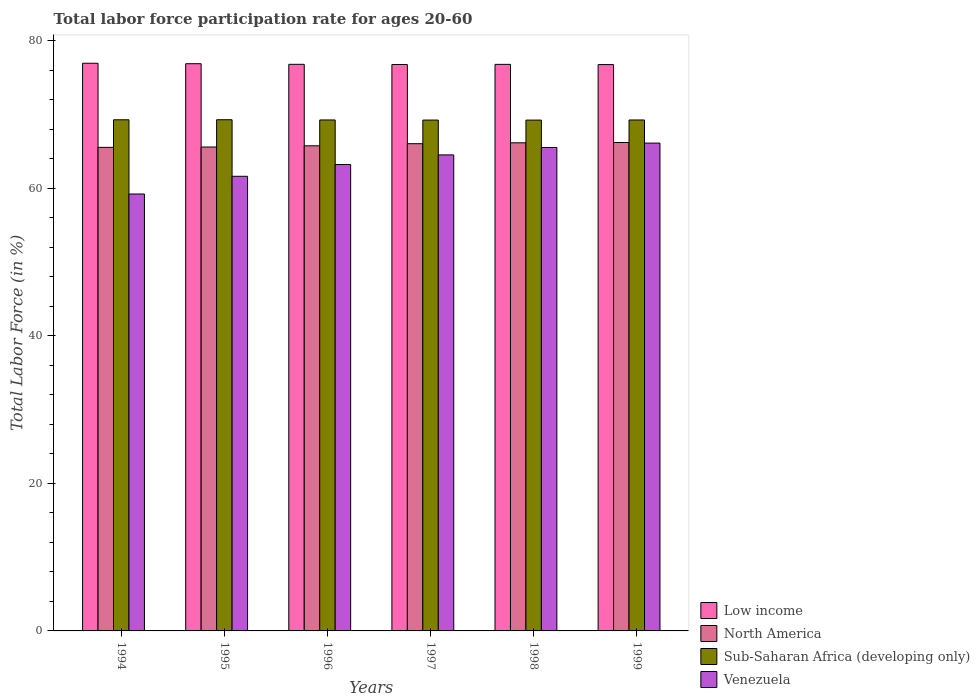How many bars are there on the 2nd tick from the left?
Give a very brief answer. 4. How many bars are there on the 2nd tick from the right?
Provide a short and direct response. 4. What is the label of the 1st group of bars from the left?
Keep it short and to the point. 1994. What is the labor force participation rate in Low income in 1994?
Offer a very short reply. 76.92. Across all years, what is the maximum labor force participation rate in Low income?
Your answer should be compact. 76.92. Across all years, what is the minimum labor force participation rate in Venezuela?
Offer a terse response. 59.2. In which year was the labor force participation rate in Sub-Saharan Africa (developing only) minimum?
Provide a succinct answer. 1998. What is the total labor force participation rate in Low income in the graph?
Your answer should be very brief. 460.79. What is the difference between the labor force participation rate in Low income in 1997 and that in 1999?
Give a very brief answer. 0.01. What is the difference between the labor force participation rate in North America in 1998 and the labor force participation rate in Low income in 1994?
Provide a succinct answer. -10.78. What is the average labor force participation rate in North America per year?
Make the answer very short. 65.86. In the year 1997, what is the difference between the labor force participation rate in North America and labor force participation rate in Sub-Saharan Africa (developing only)?
Provide a succinct answer. -3.2. In how many years, is the labor force participation rate in Venezuela greater than 8 %?
Give a very brief answer. 6. What is the ratio of the labor force participation rate in Venezuela in 1995 to that in 1997?
Make the answer very short. 0.96. Is the labor force participation rate in Sub-Saharan Africa (developing only) in 1995 less than that in 1997?
Make the answer very short. No. What is the difference between the highest and the second highest labor force participation rate in Sub-Saharan Africa (developing only)?
Provide a short and direct response. 0.01. What is the difference between the highest and the lowest labor force participation rate in North America?
Make the answer very short. 0.66. In how many years, is the labor force participation rate in Venezuela greater than the average labor force participation rate in Venezuela taken over all years?
Give a very brief answer. 3. Is the sum of the labor force participation rate in Venezuela in 1994 and 1996 greater than the maximum labor force participation rate in North America across all years?
Make the answer very short. Yes. Is it the case that in every year, the sum of the labor force participation rate in Sub-Saharan Africa (developing only) and labor force participation rate in Low income is greater than the sum of labor force participation rate in North America and labor force participation rate in Venezuela?
Give a very brief answer. Yes. What does the 3rd bar from the left in 1995 represents?
Your answer should be compact. Sub-Saharan Africa (developing only). What does the 1st bar from the right in 1998 represents?
Keep it short and to the point. Venezuela. Are all the bars in the graph horizontal?
Your answer should be compact. No. How many years are there in the graph?
Keep it short and to the point. 6. Does the graph contain any zero values?
Keep it short and to the point. No. Where does the legend appear in the graph?
Provide a succinct answer. Bottom right. How are the legend labels stacked?
Provide a short and direct response. Vertical. What is the title of the graph?
Provide a succinct answer. Total labor force participation rate for ages 20-60. Does "Fiji" appear as one of the legend labels in the graph?
Offer a terse response. No. What is the label or title of the Y-axis?
Your response must be concise. Total Labor Force (in %). What is the Total Labor Force (in %) of Low income in 1994?
Give a very brief answer. 76.92. What is the Total Labor Force (in %) in North America in 1994?
Keep it short and to the point. 65.52. What is the Total Labor Force (in %) in Sub-Saharan Africa (developing only) in 1994?
Provide a short and direct response. 69.26. What is the Total Labor Force (in %) of Venezuela in 1994?
Make the answer very short. 59.2. What is the Total Labor Force (in %) of Low income in 1995?
Offer a very short reply. 76.86. What is the Total Labor Force (in %) of North America in 1995?
Offer a terse response. 65.57. What is the Total Labor Force (in %) of Sub-Saharan Africa (developing only) in 1995?
Provide a short and direct response. 69.26. What is the Total Labor Force (in %) in Venezuela in 1995?
Your answer should be compact. 61.6. What is the Total Labor Force (in %) of Low income in 1996?
Your response must be concise. 76.77. What is the Total Labor Force (in %) of North America in 1996?
Provide a succinct answer. 65.73. What is the Total Labor Force (in %) in Sub-Saharan Africa (developing only) in 1996?
Give a very brief answer. 69.23. What is the Total Labor Force (in %) in Venezuela in 1996?
Provide a short and direct response. 63.2. What is the Total Labor Force (in %) in Low income in 1997?
Your answer should be very brief. 76.74. What is the Total Labor Force (in %) of North America in 1997?
Ensure brevity in your answer.  66.02. What is the Total Labor Force (in %) of Sub-Saharan Africa (developing only) in 1997?
Offer a terse response. 69.22. What is the Total Labor Force (in %) of Venezuela in 1997?
Provide a succinct answer. 64.5. What is the Total Labor Force (in %) in Low income in 1998?
Your answer should be compact. 76.77. What is the Total Labor Force (in %) in North America in 1998?
Your answer should be very brief. 66.14. What is the Total Labor Force (in %) of Sub-Saharan Africa (developing only) in 1998?
Keep it short and to the point. 69.21. What is the Total Labor Force (in %) of Venezuela in 1998?
Offer a very short reply. 65.5. What is the Total Labor Force (in %) in Low income in 1999?
Offer a very short reply. 76.74. What is the Total Labor Force (in %) in North America in 1999?
Your response must be concise. 66.18. What is the Total Labor Force (in %) of Sub-Saharan Africa (developing only) in 1999?
Provide a succinct answer. 69.23. What is the Total Labor Force (in %) of Venezuela in 1999?
Make the answer very short. 66.1. Across all years, what is the maximum Total Labor Force (in %) in Low income?
Keep it short and to the point. 76.92. Across all years, what is the maximum Total Labor Force (in %) of North America?
Ensure brevity in your answer.  66.18. Across all years, what is the maximum Total Labor Force (in %) of Sub-Saharan Africa (developing only)?
Offer a terse response. 69.26. Across all years, what is the maximum Total Labor Force (in %) in Venezuela?
Provide a succinct answer. 66.1. Across all years, what is the minimum Total Labor Force (in %) of Low income?
Your response must be concise. 76.74. Across all years, what is the minimum Total Labor Force (in %) of North America?
Your response must be concise. 65.52. Across all years, what is the minimum Total Labor Force (in %) in Sub-Saharan Africa (developing only)?
Offer a terse response. 69.21. Across all years, what is the minimum Total Labor Force (in %) in Venezuela?
Offer a very short reply. 59.2. What is the total Total Labor Force (in %) in Low income in the graph?
Your answer should be compact. 460.79. What is the total Total Labor Force (in %) in North America in the graph?
Offer a terse response. 395.15. What is the total Total Labor Force (in %) of Sub-Saharan Africa (developing only) in the graph?
Keep it short and to the point. 415.42. What is the total Total Labor Force (in %) in Venezuela in the graph?
Your response must be concise. 380.1. What is the difference between the Total Labor Force (in %) of Low income in 1994 and that in 1995?
Offer a very short reply. 0.06. What is the difference between the Total Labor Force (in %) of North America in 1994 and that in 1995?
Keep it short and to the point. -0.05. What is the difference between the Total Labor Force (in %) in Sub-Saharan Africa (developing only) in 1994 and that in 1995?
Make the answer very short. -0.01. What is the difference between the Total Labor Force (in %) of Low income in 1994 and that in 1996?
Your response must be concise. 0.14. What is the difference between the Total Labor Force (in %) in North America in 1994 and that in 1996?
Keep it short and to the point. -0.21. What is the difference between the Total Labor Force (in %) in Sub-Saharan Africa (developing only) in 1994 and that in 1996?
Your response must be concise. 0.02. What is the difference between the Total Labor Force (in %) of Venezuela in 1994 and that in 1996?
Ensure brevity in your answer.  -4. What is the difference between the Total Labor Force (in %) of Low income in 1994 and that in 1997?
Offer a terse response. 0.17. What is the difference between the Total Labor Force (in %) of North America in 1994 and that in 1997?
Keep it short and to the point. -0.5. What is the difference between the Total Labor Force (in %) of Sub-Saharan Africa (developing only) in 1994 and that in 1997?
Provide a succinct answer. 0.04. What is the difference between the Total Labor Force (in %) of Venezuela in 1994 and that in 1997?
Make the answer very short. -5.3. What is the difference between the Total Labor Force (in %) of Low income in 1994 and that in 1998?
Your response must be concise. 0.15. What is the difference between the Total Labor Force (in %) of North America in 1994 and that in 1998?
Keep it short and to the point. -0.62. What is the difference between the Total Labor Force (in %) in Sub-Saharan Africa (developing only) in 1994 and that in 1998?
Your answer should be compact. 0.04. What is the difference between the Total Labor Force (in %) in Venezuela in 1994 and that in 1998?
Your answer should be compact. -6.3. What is the difference between the Total Labor Force (in %) in Low income in 1994 and that in 1999?
Keep it short and to the point. 0.18. What is the difference between the Total Labor Force (in %) in North America in 1994 and that in 1999?
Your response must be concise. -0.66. What is the difference between the Total Labor Force (in %) of Sub-Saharan Africa (developing only) in 1994 and that in 1999?
Your response must be concise. 0.03. What is the difference between the Total Labor Force (in %) in Venezuela in 1994 and that in 1999?
Offer a very short reply. -6.9. What is the difference between the Total Labor Force (in %) of Low income in 1995 and that in 1996?
Provide a short and direct response. 0.08. What is the difference between the Total Labor Force (in %) of North America in 1995 and that in 1996?
Keep it short and to the point. -0.16. What is the difference between the Total Labor Force (in %) of Sub-Saharan Africa (developing only) in 1995 and that in 1996?
Your response must be concise. 0.03. What is the difference between the Total Labor Force (in %) of Venezuela in 1995 and that in 1996?
Your answer should be very brief. -1.6. What is the difference between the Total Labor Force (in %) of Low income in 1995 and that in 1997?
Provide a succinct answer. 0.11. What is the difference between the Total Labor Force (in %) in North America in 1995 and that in 1997?
Your answer should be very brief. -0.45. What is the difference between the Total Labor Force (in %) of Sub-Saharan Africa (developing only) in 1995 and that in 1997?
Your answer should be very brief. 0.04. What is the difference between the Total Labor Force (in %) of Venezuela in 1995 and that in 1997?
Your answer should be very brief. -2.9. What is the difference between the Total Labor Force (in %) of Low income in 1995 and that in 1998?
Your answer should be compact. 0.09. What is the difference between the Total Labor Force (in %) in North America in 1995 and that in 1998?
Your answer should be compact. -0.57. What is the difference between the Total Labor Force (in %) in Sub-Saharan Africa (developing only) in 1995 and that in 1998?
Keep it short and to the point. 0.05. What is the difference between the Total Labor Force (in %) in Venezuela in 1995 and that in 1998?
Make the answer very short. -3.9. What is the difference between the Total Labor Force (in %) of Low income in 1995 and that in 1999?
Your response must be concise. 0.12. What is the difference between the Total Labor Force (in %) of North America in 1995 and that in 1999?
Keep it short and to the point. -0.61. What is the difference between the Total Labor Force (in %) in Sub-Saharan Africa (developing only) in 1995 and that in 1999?
Provide a short and direct response. 0.03. What is the difference between the Total Labor Force (in %) of Venezuela in 1995 and that in 1999?
Keep it short and to the point. -4.5. What is the difference between the Total Labor Force (in %) in Low income in 1996 and that in 1997?
Keep it short and to the point. 0.03. What is the difference between the Total Labor Force (in %) of North America in 1996 and that in 1997?
Your response must be concise. -0.29. What is the difference between the Total Labor Force (in %) of Sub-Saharan Africa (developing only) in 1996 and that in 1997?
Your answer should be very brief. 0.01. What is the difference between the Total Labor Force (in %) of Low income in 1996 and that in 1998?
Provide a short and direct response. 0.01. What is the difference between the Total Labor Force (in %) of North America in 1996 and that in 1998?
Keep it short and to the point. -0.41. What is the difference between the Total Labor Force (in %) of Sub-Saharan Africa (developing only) in 1996 and that in 1998?
Keep it short and to the point. 0.02. What is the difference between the Total Labor Force (in %) in Venezuela in 1996 and that in 1998?
Give a very brief answer. -2.3. What is the difference between the Total Labor Force (in %) of Low income in 1996 and that in 1999?
Ensure brevity in your answer.  0.04. What is the difference between the Total Labor Force (in %) in North America in 1996 and that in 1999?
Ensure brevity in your answer.  -0.45. What is the difference between the Total Labor Force (in %) of Sub-Saharan Africa (developing only) in 1996 and that in 1999?
Your response must be concise. 0. What is the difference between the Total Labor Force (in %) in Low income in 1997 and that in 1998?
Provide a short and direct response. -0.02. What is the difference between the Total Labor Force (in %) of North America in 1997 and that in 1998?
Your answer should be compact. -0.12. What is the difference between the Total Labor Force (in %) in Sub-Saharan Africa (developing only) in 1997 and that in 1998?
Provide a short and direct response. 0. What is the difference between the Total Labor Force (in %) of Low income in 1997 and that in 1999?
Keep it short and to the point. 0.01. What is the difference between the Total Labor Force (in %) in North America in 1997 and that in 1999?
Your answer should be very brief. -0.16. What is the difference between the Total Labor Force (in %) of Sub-Saharan Africa (developing only) in 1997 and that in 1999?
Provide a short and direct response. -0.01. What is the difference between the Total Labor Force (in %) in Low income in 1998 and that in 1999?
Offer a very short reply. 0.03. What is the difference between the Total Labor Force (in %) of North America in 1998 and that in 1999?
Ensure brevity in your answer.  -0.04. What is the difference between the Total Labor Force (in %) in Sub-Saharan Africa (developing only) in 1998 and that in 1999?
Offer a very short reply. -0.02. What is the difference between the Total Labor Force (in %) in Venezuela in 1998 and that in 1999?
Offer a very short reply. -0.6. What is the difference between the Total Labor Force (in %) in Low income in 1994 and the Total Labor Force (in %) in North America in 1995?
Ensure brevity in your answer.  11.35. What is the difference between the Total Labor Force (in %) in Low income in 1994 and the Total Labor Force (in %) in Sub-Saharan Africa (developing only) in 1995?
Make the answer very short. 7.65. What is the difference between the Total Labor Force (in %) of Low income in 1994 and the Total Labor Force (in %) of Venezuela in 1995?
Keep it short and to the point. 15.32. What is the difference between the Total Labor Force (in %) in North America in 1994 and the Total Labor Force (in %) in Sub-Saharan Africa (developing only) in 1995?
Provide a succinct answer. -3.74. What is the difference between the Total Labor Force (in %) in North America in 1994 and the Total Labor Force (in %) in Venezuela in 1995?
Ensure brevity in your answer.  3.92. What is the difference between the Total Labor Force (in %) in Sub-Saharan Africa (developing only) in 1994 and the Total Labor Force (in %) in Venezuela in 1995?
Give a very brief answer. 7.66. What is the difference between the Total Labor Force (in %) of Low income in 1994 and the Total Labor Force (in %) of North America in 1996?
Ensure brevity in your answer.  11.19. What is the difference between the Total Labor Force (in %) of Low income in 1994 and the Total Labor Force (in %) of Sub-Saharan Africa (developing only) in 1996?
Your answer should be compact. 7.68. What is the difference between the Total Labor Force (in %) in Low income in 1994 and the Total Labor Force (in %) in Venezuela in 1996?
Keep it short and to the point. 13.72. What is the difference between the Total Labor Force (in %) in North America in 1994 and the Total Labor Force (in %) in Sub-Saharan Africa (developing only) in 1996?
Offer a terse response. -3.71. What is the difference between the Total Labor Force (in %) in North America in 1994 and the Total Labor Force (in %) in Venezuela in 1996?
Make the answer very short. 2.32. What is the difference between the Total Labor Force (in %) in Sub-Saharan Africa (developing only) in 1994 and the Total Labor Force (in %) in Venezuela in 1996?
Provide a succinct answer. 6.06. What is the difference between the Total Labor Force (in %) in Low income in 1994 and the Total Labor Force (in %) in North America in 1997?
Offer a very short reply. 10.9. What is the difference between the Total Labor Force (in %) in Low income in 1994 and the Total Labor Force (in %) in Sub-Saharan Africa (developing only) in 1997?
Offer a very short reply. 7.7. What is the difference between the Total Labor Force (in %) in Low income in 1994 and the Total Labor Force (in %) in Venezuela in 1997?
Make the answer very short. 12.42. What is the difference between the Total Labor Force (in %) of North America in 1994 and the Total Labor Force (in %) of Sub-Saharan Africa (developing only) in 1997?
Offer a terse response. -3.7. What is the difference between the Total Labor Force (in %) of North America in 1994 and the Total Labor Force (in %) of Venezuela in 1997?
Offer a very short reply. 1.02. What is the difference between the Total Labor Force (in %) in Sub-Saharan Africa (developing only) in 1994 and the Total Labor Force (in %) in Venezuela in 1997?
Your answer should be very brief. 4.76. What is the difference between the Total Labor Force (in %) in Low income in 1994 and the Total Labor Force (in %) in North America in 1998?
Your answer should be compact. 10.78. What is the difference between the Total Labor Force (in %) in Low income in 1994 and the Total Labor Force (in %) in Sub-Saharan Africa (developing only) in 1998?
Make the answer very short. 7.7. What is the difference between the Total Labor Force (in %) in Low income in 1994 and the Total Labor Force (in %) in Venezuela in 1998?
Make the answer very short. 11.42. What is the difference between the Total Labor Force (in %) of North America in 1994 and the Total Labor Force (in %) of Sub-Saharan Africa (developing only) in 1998?
Provide a succinct answer. -3.69. What is the difference between the Total Labor Force (in %) in North America in 1994 and the Total Labor Force (in %) in Venezuela in 1998?
Give a very brief answer. 0.02. What is the difference between the Total Labor Force (in %) of Sub-Saharan Africa (developing only) in 1994 and the Total Labor Force (in %) of Venezuela in 1998?
Provide a succinct answer. 3.76. What is the difference between the Total Labor Force (in %) in Low income in 1994 and the Total Labor Force (in %) in North America in 1999?
Provide a short and direct response. 10.74. What is the difference between the Total Labor Force (in %) of Low income in 1994 and the Total Labor Force (in %) of Sub-Saharan Africa (developing only) in 1999?
Your answer should be very brief. 7.68. What is the difference between the Total Labor Force (in %) of Low income in 1994 and the Total Labor Force (in %) of Venezuela in 1999?
Offer a terse response. 10.82. What is the difference between the Total Labor Force (in %) in North America in 1994 and the Total Labor Force (in %) in Sub-Saharan Africa (developing only) in 1999?
Ensure brevity in your answer.  -3.71. What is the difference between the Total Labor Force (in %) of North America in 1994 and the Total Labor Force (in %) of Venezuela in 1999?
Provide a succinct answer. -0.58. What is the difference between the Total Labor Force (in %) in Sub-Saharan Africa (developing only) in 1994 and the Total Labor Force (in %) in Venezuela in 1999?
Provide a succinct answer. 3.16. What is the difference between the Total Labor Force (in %) of Low income in 1995 and the Total Labor Force (in %) of North America in 1996?
Offer a very short reply. 11.13. What is the difference between the Total Labor Force (in %) of Low income in 1995 and the Total Labor Force (in %) of Sub-Saharan Africa (developing only) in 1996?
Provide a short and direct response. 7.62. What is the difference between the Total Labor Force (in %) of Low income in 1995 and the Total Labor Force (in %) of Venezuela in 1996?
Offer a very short reply. 13.66. What is the difference between the Total Labor Force (in %) of North America in 1995 and the Total Labor Force (in %) of Sub-Saharan Africa (developing only) in 1996?
Your answer should be compact. -3.66. What is the difference between the Total Labor Force (in %) of North America in 1995 and the Total Labor Force (in %) of Venezuela in 1996?
Provide a short and direct response. 2.37. What is the difference between the Total Labor Force (in %) of Sub-Saharan Africa (developing only) in 1995 and the Total Labor Force (in %) of Venezuela in 1996?
Offer a terse response. 6.06. What is the difference between the Total Labor Force (in %) of Low income in 1995 and the Total Labor Force (in %) of North America in 1997?
Provide a short and direct response. 10.84. What is the difference between the Total Labor Force (in %) in Low income in 1995 and the Total Labor Force (in %) in Sub-Saharan Africa (developing only) in 1997?
Offer a terse response. 7.64. What is the difference between the Total Labor Force (in %) of Low income in 1995 and the Total Labor Force (in %) of Venezuela in 1997?
Your response must be concise. 12.36. What is the difference between the Total Labor Force (in %) of North America in 1995 and the Total Labor Force (in %) of Sub-Saharan Africa (developing only) in 1997?
Your answer should be compact. -3.65. What is the difference between the Total Labor Force (in %) in North America in 1995 and the Total Labor Force (in %) in Venezuela in 1997?
Ensure brevity in your answer.  1.07. What is the difference between the Total Labor Force (in %) in Sub-Saharan Africa (developing only) in 1995 and the Total Labor Force (in %) in Venezuela in 1997?
Offer a terse response. 4.76. What is the difference between the Total Labor Force (in %) of Low income in 1995 and the Total Labor Force (in %) of North America in 1998?
Offer a very short reply. 10.72. What is the difference between the Total Labor Force (in %) of Low income in 1995 and the Total Labor Force (in %) of Sub-Saharan Africa (developing only) in 1998?
Offer a terse response. 7.64. What is the difference between the Total Labor Force (in %) in Low income in 1995 and the Total Labor Force (in %) in Venezuela in 1998?
Provide a short and direct response. 11.36. What is the difference between the Total Labor Force (in %) in North America in 1995 and the Total Labor Force (in %) in Sub-Saharan Africa (developing only) in 1998?
Your answer should be very brief. -3.64. What is the difference between the Total Labor Force (in %) in North America in 1995 and the Total Labor Force (in %) in Venezuela in 1998?
Provide a succinct answer. 0.07. What is the difference between the Total Labor Force (in %) of Sub-Saharan Africa (developing only) in 1995 and the Total Labor Force (in %) of Venezuela in 1998?
Your answer should be compact. 3.76. What is the difference between the Total Labor Force (in %) in Low income in 1995 and the Total Labor Force (in %) in North America in 1999?
Your answer should be very brief. 10.68. What is the difference between the Total Labor Force (in %) in Low income in 1995 and the Total Labor Force (in %) in Sub-Saharan Africa (developing only) in 1999?
Make the answer very short. 7.62. What is the difference between the Total Labor Force (in %) in Low income in 1995 and the Total Labor Force (in %) in Venezuela in 1999?
Offer a very short reply. 10.76. What is the difference between the Total Labor Force (in %) of North America in 1995 and the Total Labor Force (in %) of Sub-Saharan Africa (developing only) in 1999?
Ensure brevity in your answer.  -3.66. What is the difference between the Total Labor Force (in %) of North America in 1995 and the Total Labor Force (in %) of Venezuela in 1999?
Your answer should be very brief. -0.53. What is the difference between the Total Labor Force (in %) in Sub-Saharan Africa (developing only) in 1995 and the Total Labor Force (in %) in Venezuela in 1999?
Provide a short and direct response. 3.16. What is the difference between the Total Labor Force (in %) of Low income in 1996 and the Total Labor Force (in %) of North America in 1997?
Your answer should be compact. 10.75. What is the difference between the Total Labor Force (in %) in Low income in 1996 and the Total Labor Force (in %) in Sub-Saharan Africa (developing only) in 1997?
Offer a very short reply. 7.55. What is the difference between the Total Labor Force (in %) in Low income in 1996 and the Total Labor Force (in %) in Venezuela in 1997?
Offer a terse response. 12.27. What is the difference between the Total Labor Force (in %) in North America in 1996 and the Total Labor Force (in %) in Sub-Saharan Africa (developing only) in 1997?
Ensure brevity in your answer.  -3.49. What is the difference between the Total Labor Force (in %) of North America in 1996 and the Total Labor Force (in %) of Venezuela in 1997?
Offer a very short reply. 1.23. What is the difference between the Total Labor Force (in %) of Sub-Saharan Africa (developing only) in 1996 and the Total Labor Force (in %) of Venezuela in 1997?
Make the answer very short. 4.73. What is the difference between the Total Labor Force (in %) in Low income in 1996 and the Total Labor Force (in %) in North America in 1998?
Provide a short and direct response. 10.63. What is the difference between the Total Labor Force (in %) of Low income in 1996 and the Total Labor Force (in %) of Sub-Saharan Africa (developing only) in 1998?
Give a very brief answer. 7.56. What is the difference between the Total Labor Force (in %) in Low income in 1996 and the Total Labor Force (in %) in Venezuela in 1998?
Offer a terse response. 11.27. What is the difference between the Total Labor Force (in %) of North America in 1996 and the Total Labor Force (in %) of Sub-Saharan Africa (developing only) in 1998?
Offer a terse response. -3.49. What is the difference between the Total Labor Force (in %) of North America in 1996 and the Total Labor Force (in %) of Venezuela in 1998?
Keep it short and to the point. 0.23. What is the difference between the Total Labor Force (in %) of Sub-Saharan Africa (developing only) in 1996 and the Total Labor Force (in %) of Venezuela in 1998?
Provide a short and direct response. 3.73. What is the difference between the Total Labor Force (in %) of Low income in 1996 and the Total Labor Force (in %) of North America in 1999?
Your response must be concise. 10.59. What is the difference between the Total Labor Force (in %) of Low income in 1996 and the Total Labor Force (in %) of Sub-Saharan Africa (developing only) in 1999?
Provide a succinct answer. 7.54. What is the difference between the Total Labor Force (in %) in Low income in 1996 and the Total Labor Force (in %) in Venezuela in 1999?
Ensure brevity in your answer.  10.67. What is the difference between the Total Labor Force (in %) of North America in 1996 and the Total Labor Force (in %) of Sub-Saharan Africa (developing only) in 1999?
Provide a succinct answer. -3.5. What is the difference between the Total Labor Force (in %) in North America in 1996 and the Total Labor Force (in %) in Venezuela in 1999?
Give a very brief answer. -0.37. What is the difference between the Total Labor Force (in %) of Sub-Saharan Africa (developing only) in 1996 and the Total Labor Force (in %) of Venezuela in 1999?
Make the answer very short. 3.13. What is the difference between the Total Labor Force (in %) in Low income in 1997 and the Total Labor Force (in %) in North America in 1998?
Offer a very short reply. 10.61. What is the difference between the Total Labor Force (in %) in Low income in 1997 and the Total Labor Force (in %) in Sub-Saharan Africa (developing only) in 1998?
Offer a terse response. 7.53. What is the difference between the Total Labor Force (in %) in Low income in 1997 and the Total Labor Force (in %) in Venezuela in 1998?
Your response must be concise. 11.24. What is the difference between the Total Labor Force (in %) in North America in 1997 and the Total Labor Force (in %) in Sub-Saharan Africa (developing only) in 1998?
Your answer should be very brief. -3.2. What is the difference between the Total Labor Force (in %) of North America in 1997 and the Total Labor Force (in %) of Venezuela in 1998?
Your answer should be compact. 0.52. What is the difference between the Total Labor Force (in %) in Sub-Saharan Africa (developing only) in 1997 and the Total Labor Force (in %) in Venezuela in 1998?
Keep it short and to the point. 3.72. What is the difference between the Total Labor Force (in %) in Low income in 1997 and the Total Labor Force (in %) in North America in 1999?
Offer a very short reply. 10.57. What is the difference between the Total Labor Force (in %) of Low income in 1997 and the Total Labor Force (in %) of Sub-Saharan Africa (developing only) in 1999?
Give a very brief answer. 7.51. What is the difference between the Total Labor Force (in %) in Low income in 1997 and the Total Labor Force (in %) in Venezuela in 1999?
Make the answer very short. 10.64. What is the difference between the Total Labor Force (in %) in North America in 1997 and the Total Labor Force (in %) in Sub-Saharan Africa (developing only) in 1999?
Your answer should be compact. -3.21. What is the difference between the Total Labor Force (in %) of North America in 1997 and the Total Labor Force (in %) of Venezuela in 1999?
Your answer should be compact. -0.08. What is the difference between the Total Labor Force (in %) of Sub-Saharan Africa (developing only) in 1997 and the Total Labor Force (in %) of Venezuela in 1999?
Your answer should be compact. 3.12. What is the difference between the Total Labor Force (in %) in Low income in 1998 and the Total Labor Force (in %) in North America in 1999?
Your answer should be very brief. 10.59. What is the difference between the Total Labor Force (in %) of Low income in 1998 and the Total Labor Force (in %) of Sub-Saharan Africa (developing only) in 1999?
Offer a very short reply. 7.53. What is the difference between the Total Labor Force (in %) in Low income in 1998 and the Total Labor Force (in %) in Venezuela in 1999?
Keep it short and to the point. 10.67. What is the difference between the Total Labor Force (in %) of North America in 1998 and the Total Labor Force (in %) of Sub-Saharan Africa (developing only) in 1999?
Make the answer very short. -3.09. What is the difference between the Total Labor Force (in %) in North America in 1998 and the Total Labor Force (in %) in Venezuela in 1999?
Offer a very short reply. 0.04. What is the difference between the Total Labor Force (in %) in Sub-Saharan Africa (developing only) in 1998 and the Total Labor Force (in %) in Venezuela in 1999?
Offer a terse response. 3.11. What is the average Total Labor Force (in %) in Low income per year?
Make the answer very short. 76.8. What is the average Total Labor Force (in %) of North America per year?
Give a very brief answer. 65.86. What is the average Total Labor Force (in %) of Sub-Saharan Africa (developing only) per year?
Your answer should be compact. 69.24. What is the average Total Labor Force (in %) of Venezuela per year?
Ensure brevity in your answer.  63.35. In the year 1994, what is the difference between the Total Labor Force (in %) of Low income and Total Labor Force (in %) of North America?
Provide a succinct answer. 11.4. In the year 1994, what is the difference between the Total Labor Force (in %) of Low income and Total Labor Force (in %) of Sub-Saharan Africa (developing only)?
Your answer should be compact. 7.66. In the year 1994, what is the difference between the Total Labor Force (in %) of Low income and Total Labor Force (in %) of Venezuela?
Keep it short and to the point. 17.72. In the year 1994, what is the difference between the Total Labor Force (in %) of North America and Total Labor Force (in %) of Sub-Saharan Africa (developing only)?
Provide a succinct answer. -3.74. In the year 1994, what is the difference between the Total Labor Force (in %) of North America and Total Labor Force (in %) of Venezuela?
Offer a terse response. 6.32. In the year 1994, what is the difference between the Total Labor Force (in %) in Sub-Saharan Africa (developing only) and Total Labor Force (in %) in Venezuela?
Your answer should be compact. 10.06. In the year 1995, what is the difference between the Total Labor Force (in %) in Low income and Total Labor Force (in %) in North America?
Ensure brevity in your answer.  11.29. In the year 1995, what is the difference between the Total Labor Force (in %) in Low income and Total Labor Force (in %) in Sub-Saharan Africa (developing only)?
Offer a very short reply. 7.59. In the year 1995, what is the difference between the Total Labor Force (in %) of Low income and Total Labor Force (in %) of Venezuela?
Your response must be concise. 15.26. In the year 1995, what is the difference between the Total Labor Force (in %) in North America and Total Labor Force (in %) in Sub-Saharan Africa (developing only)?
Your answer should be compact. -3.69. In the year 1995, what is the difference between the Total Labor Force (in %) in North America and Total Labor Force (in %) in Venezuela?
Provide a succinct answer. 3.97. In the year 1995, what is the difference between the Total Labor Force (in %) in Sub-Saharan Africa (developing only) and Total Labor Force (in %) in Venezuela?
Keep it short and to the point. 7.66. In the year 1996, what is the difference between the Total Labor Force (in %) of Low income and Total Labor Force (in %) of North America?
Provide a short and direct response. 11.04. In the year 1996, what is the difference between the Total Labor Force (in %) of Low income and Total Labor Force (in %) of Sub-Saharan Africa (developing only)?
Your answer should be compact. 7.54. In the year 1996, what is the difference between the Total Labor Force (in %) of Low income and Total Labor Force (in %) of Venezuela?
Give a very brief answer. 13.57. In the year 1996, what is the difference between the Total Labor Force (in %) of North America and Total Labor Force (in %) of Sub-Saharan Africa (developing only)?
Your answer should be compact. -3.5. In the year 1996, what is the difference between the Total Labor Force (in %) in North America and Total Labor Force (in %) in Venezuela?
Provide a short and direct response. 2.53. In the year 1996, what is the difference between the Total Labor Force (in %) of Sub-Saharan Africa (developing only) and Total Labor Force (in %) of Venezuela?
Give a very brief answer. 6.03. In the year 1997, what is the difference between the Total Labor Force (in %) in Low income and Total Labor Force (in %) in North America?
Your answer should be compact. 10.73. In the year 1997, what is the difference between the Total Labor Force (in %) in Low income and Total Labor Force (in %) in Sub-Saharan Africa (developing only)?
Offer a terse response. 7.53. In the year 1997, what is the difference between the Total Labor Force (in %) in Low income and Total Labor Force (in %) in Venezuela?
Your answer should be compact. 12.24. In the year 1997, what is the difference between the Total Labor Force (in %) of North America and Total Labor Force (in %) of Sub-Saharan Africa (developing only)?
Give a very brief answer. -3.2. In the year 1997, what is the difference between the Total Labor Force (in %) of North America and Total Labor Force (in %) of Venezuela?
Make the answer very short. 1.52. In the year 1997, what is the difference between the Total Labor Force (in %) in Sub-Saharan Africa (developing only) and Total Labor Force (in %) in Venezuela?
Offer a very short reply. 4.72. In the year 1998, what is the difference between the Total Labor Force (in %) of Low income and Total Labor Force (in %) of North America?
Your response must be concise. 10.63. In the year 1998, what is the difference between the Total Labor Force (in %) in Low income and Total Labor Force (in %) in Sub-Saharan Africa (developing only)?
Ensure brevity in your answer.  7.55. In the year 1998, what is the difference between the Total Labor Force (in %) of Low income and Total Labor Force (in %) of Venezuela?
Your response must be concise. 11.27. In the year 1998, what is the difference between the Total Labor Force (in %) in North America and Total Labor Force (in %) in Sub-Saharan Africa (developing only)?
Ensure brevity in your answer.  -3.08. In the year 1998, what is the difference between the Total Labor Force (in %) of North America and Total Labor Force (in %) of Venezuela?
Give a very brief answer. 0.64. In the year 1998, what is the difference between the Total Labor Force (in %) of Sub-Saharan Africa (developing only) and Total Labor Force (in %) of Venezuela?
Offer a terse response. 3.71. In the year 1999, what is the difference between the Total Labor Force (in %) of Low income and Total Labor Force (in %) of North America?
Provide a short and direct response. 10.56. In the year 1999, what is the difference between the Total Labor Force (in %) of Low income and Total Labor Force (in %) of Sub-Saharan Africa (developing only)?
Your answer should be compact. 7.51. In the year 1999, what is the difference between the Total Labor Force (in %) in Low income and Total Labor Force (in %) in Venezuela?
Ensure brevity in your answer.  10.64. In the year 1999, what is the difference between the Total Labor Force (in %) of North America and Total Labor Force (in %) of Sub-Saharan Africa (developing only)?
Give a very brief answer. -3.05. In the year 1999, what is the difference between the Total Labor Force (in %) of North America and Total Labor Force (in %) of Venezuela?
Give a very brief answer. 0.08. In the year 1999, what is the difference between the Total Labor Force (in %) in Sub-Saharan Africa (developing only) and Total Labor Force (in %) in Venezuela?
Give a very brief answer. 3.13. What is the ratio of the Total Labor Force (in %) of North America in 1994 to that in 1995?
Ensure brevity in your answer.  1. What is the ratio of the Total Labor Force (in %) of Sub-Saharan Africa (developing only) in 1994 to that in 1995?
Provide a succinct answer. 1. What is the ratio of the Total Labor Force (in %) of Venezuela in 1994 to that in 1995?
Keep it short and to the point. 0.96. What is the ratio of the Total Labor Force (in %) of Low income in 1994 to that in 1996?
Your response must be concise. 1. What is the ratio of the Total Labor Force (in %) of Sub-Saharan Africa (developing only) in 1994 to that in 1996?
Make the answer very short. 1. What is the ratio of the Total Labor Force (in %) in Venezuela in 1994 to that in 1996?
Give a very brief answer. 0.94. What is the ratio of the Total Labor Force (in %) of Low income in 1994 to that in 1997?
Ensure brevity in your answer.  1. What is the ratio of the Total Labor Force (in %) in Sub-Saharan Africa (developing only) in 1994 to that in 1997?
Provide a short and direct response. 1. What is the ratio of the Total Labor Force (in %) in Venezuela in 1994 to that in 1997?
Your answer should be compact. 0.92. What is the ratio of the Total Labor Force (in %) of Low income in 1994 to that in 1998?
Offer a terse response. 1. What is the ratio of the Total Labor Force (in %) of North America in 1994 to that in 1998?
Offer a terse response. 0.99. What is the ratio of the Total Labor Force (in %) of Venezuela in 1994 to that in 1998?
Your response must be concise. 0.9. What is the ratio of the Total Labor Force (in %) of Low income in 1994 to that in 1999?
Make the answer very short. 1. What is the ratio of the Total Labor Force (in %) of North America in 1994 to that in 1999?
Give a very brief answer. 0.99. What is the ratio of the Total Labor Force (in %) in Sub-Saharan Africa (developing only) in 1994 to that in 1999?
Your answer should be compact. 1. What is the ratio of the Total Labor Force (in %) of Venezuela in 1994 to that in 1999?
Provide a succinct answer. 0.9. What is the ratio of the Total Labor Force (in %) in Low income in 1995 to that in 1996?
Make the answer very short. 1. What is the ratio of the Total Labor Force (in %) of Venezuela in 1995 to that in 1996?
Offer a terse response. 0.97. What is the ratio of the Total Labor Force (in %) of Low income in 1995 to that in 1997?
Your answer should be very brief. 1. What is the ratio of the Total Labor Force (in %) in Venezuela in 1995 to that in 1997?
Offer a very short reply. 0.95. What is the ratio of the Total Labor Force (in %) of Venezuela in 1995 to that in 1998?
Make the answer very short. 0.94. What is the ratio of the Total Labor Force (in %) in Low income in 1995 to that in 1999?
Offer a very short reply. 1. What is the ratio of the Total Labor Force (in %) of North America in 1995 to that in 1999?
Offer a terse response. 0.99. What is the ratio of the Total Labor Force (in %) of Venezuela in 1995 to that in 1999?
Provide a short and direct response. 0.93. What is the ratio of the Total Labor Force (in %) in Low income in 1996 to that in 1997?
Your answer should be very brief. 1. What is the ratio of the Total Labor Force (in %) of Venezuela in 1996 to that in 1997?
Give a very brief answer. 0.98. What is the ratio of the Total Labor Force (in %) in Low income in 1996 to that in 1998?
Offer a very short reply. 1. What is the ratio of the Total Labor Force (in %) of Sub-Saharan Africa (developing only) in 1996 to that in 1998?
Your answer should be very brief. 1. What is the ratio of the Total Labor Force (in %) of Venezuela in 1996 to that in 1998?
Ensure brevity in your answer.  0.96. What is the ratio of the Total Labor Force (in %) in Low income in 1996 to that in 1999?
Your answer should be compact. 1. What is the ratio of the Total Labor Force (in %) in North America in 1996 to that in 1999?
Keep it short and to the point. 0.99. What is the ratio of the Total Labor Force (in %) of Venezuela in 1996 to that in 1999?
Provide a short and direct response. 0.96. What is the ratio of the Total Labor Force (in %) in Sub-Saharan Africa (developing only) in 1997 to that in 1998?
Make the answer very short. 1. What is the ratio of the Total Labor Force (in %) in Venezuela in 1997 to that in 1998?
Your answer should be very brief. 0.98. What is the ratio of the Total Labor Force (in %) in North America in 1997 to that in 1999?
Your answer should be very brief. 1. What is the ratio of the Total Labor Force (in %) of Venezuela in 1997 to that in 1999?
Offer a very short reply. 0.98. What is the ratio of the Total Labor Force (in %) of Low income in 1998 to that in 1999?
Your answer should be very brief. 1. What is the ratio of the Total Labor Force (in %) in North America in 1998 to that in 1999?
Give a very brief answer. 1. What is the ratio of the Total Labor Force (in %) of Sub-Saharan Africa (developing only) in 1998 to that in 1999?
Offer a very short reply. 1. What is the ratio of the Total Labor Force (in %) in Venezuela in 1998 to that in 1999?
Your answer should be very brief. 0.99. What is the difference between the highest and the second highest Total Labor Force (in %) of Low income?
Your response must be concise. 0.06. What is the difference between the highest and the second highest Total Labor Force (in %) of North America?
Offer a very short reply. 0.04. What is the difference between the highest and the second highest Total Labor Force (in %) in Sub-Saharan Africa (developing only)?
Provide a succinct answer. 0.01. What is the difference between the highest and the lowest Total Labor Force (in %) in Low income?
Ensure brevity in your answer.  0.18. What is the difference between the highest and the lowest Total Labor Force (in %) of North America?
Ensure brevity in your answer.  0.66. What is the difference between the highest and the lowest Total Labor Force (in %) in Sub-Saharan Africa (developing only)?
Your response must be concise. 0.05. What is the difference between the highest and the lowest Total Labor Force (in %) in Venezuela?
Provide a short and direct response. 6.9. 